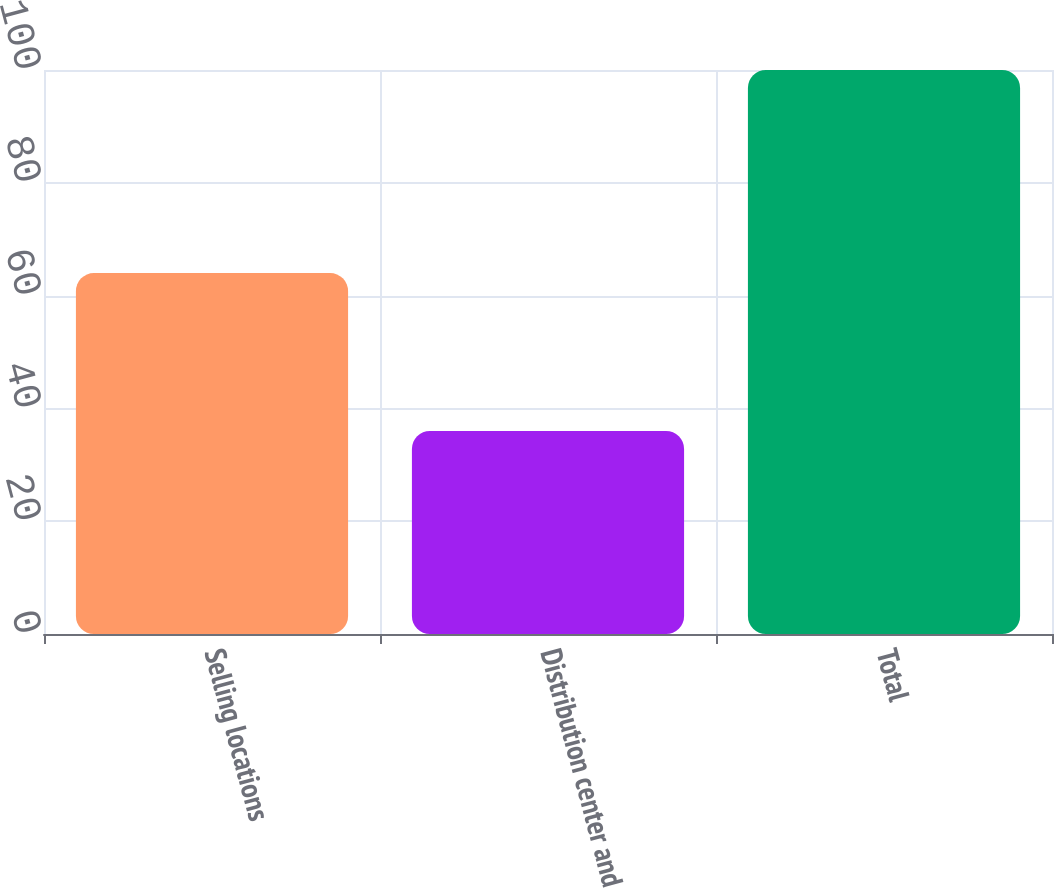Convert chart to OTSL. <chart><loc_0><loc_0><loc_500><loc_500><bar_chart><fcel>Selling locations<fcel>Distribution center and<fcel>Total<nl><fcel>64<fcel>36<fcel>100<nl></chart> 